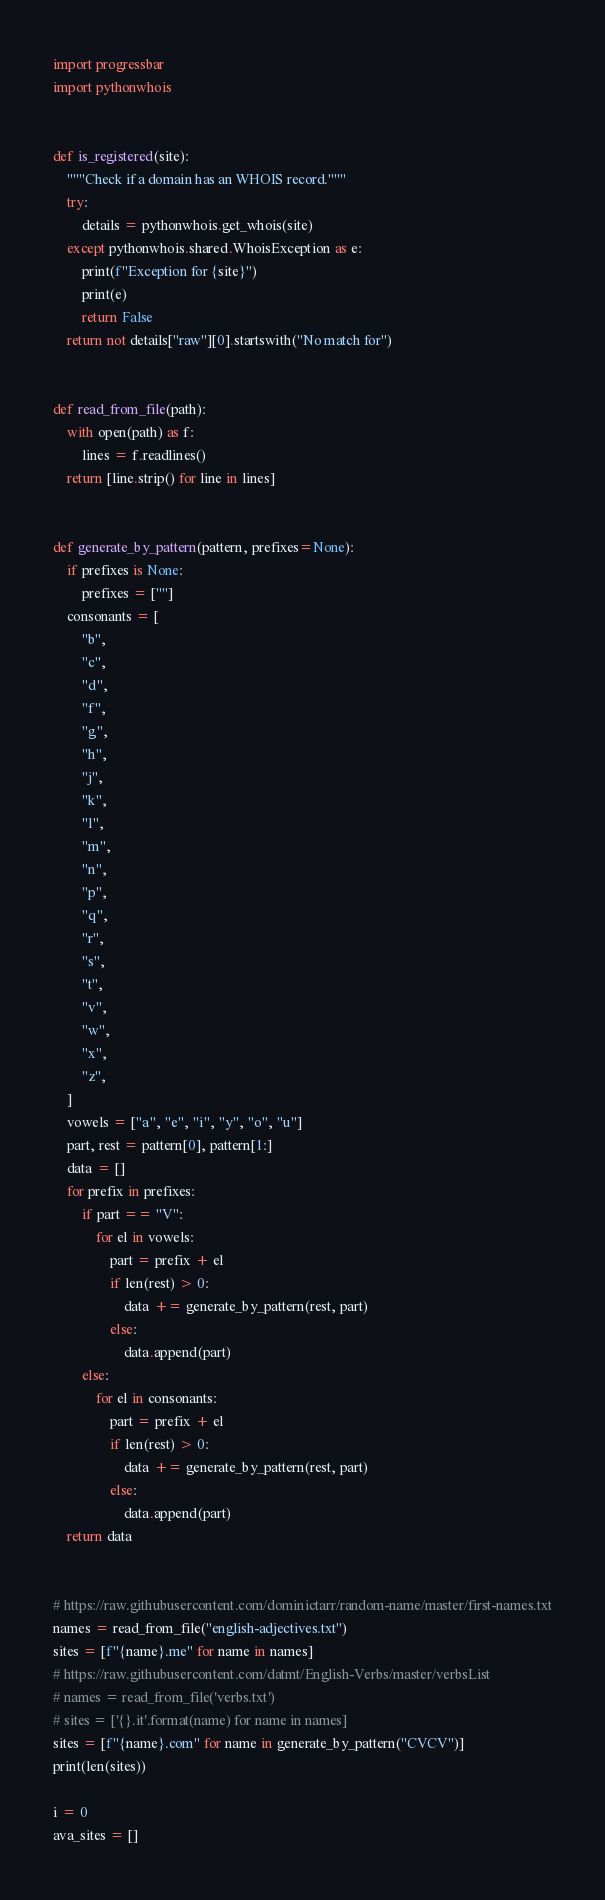Convert code to text. <code><loc_0><loc_0><loc_500><loc_500><_Python_>import progressbar
import pythonwhois


def is_registered(site):
    """Check if a domain has an WHOIS record."""
    try:
        details = pythonwhois.get_whois(site)
    except pythonwhois.shared.WhoisException as e:
        print(f"Exception for {site}")
        print(e)
        return False
    return not details["raw"][0].startswith("No match for")


def read_from_file(path):
    with open(path) as f:
        lines = f.readlines()
    return [line.strip() for line in lines]


def generate_by_pattern(pattern, prefixes=None):
    if prefixes is None:
        prefixes = [""]
    consonants = [
        "b",
        "c",
        "d",
        "f",
        "g",
        "h",
        "j",
        "k",
        "l",
        "m",
        "n",
        "p",
        "q",
        "r",
        "s",
        "t",
        "v",
        "w",
        "x",
        "z",
    ]
    vowels = ["a", "e", "i", "y", "o", "u"]
    part, rest = pattern[0], pattern[1:]
    data = []
    for prefix in prefixes:
        if part == "V":
            for el in vowels:
                part = prefix + el
                if len(rest) > 0:
                    data += generate_by_pattern(rest, part)
                else:
                    data.append(part)
        else:
            for el in consonants:
                part = prefix + el
                if len(rest) > 0:
                    data += generate_by_pattern(rest, part)
                else:
                    data.append(part)
    return data


# https://raw.githubusercontent.com/dominictarr/random-name/master/first-names.txt
names = read_from_file("english-adjectives.txt")
sites = [f"{name}.me" for name in names]
# https://raw.githubusercontent.com/datmt/English-Verbs/master/verbsList
# names = read_from_file('verbs.txt')
# sites = ['{}.it'.format(name) for name in names]
sites = [f"{name}.com" for name in generate_by_pattern("CVCV")]
print(len(sites))

i = 0
ava_sites = []</code> 